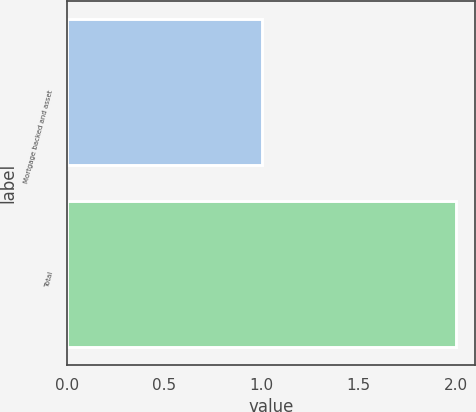Convert chart to OTSL. <chart><loc_0><loc_0><loc_500><loc_500><bar_chart><fcel>Mortgage backed and asset<fcel>Total<nl><fcel>1<fcel>2<nl></chart> 